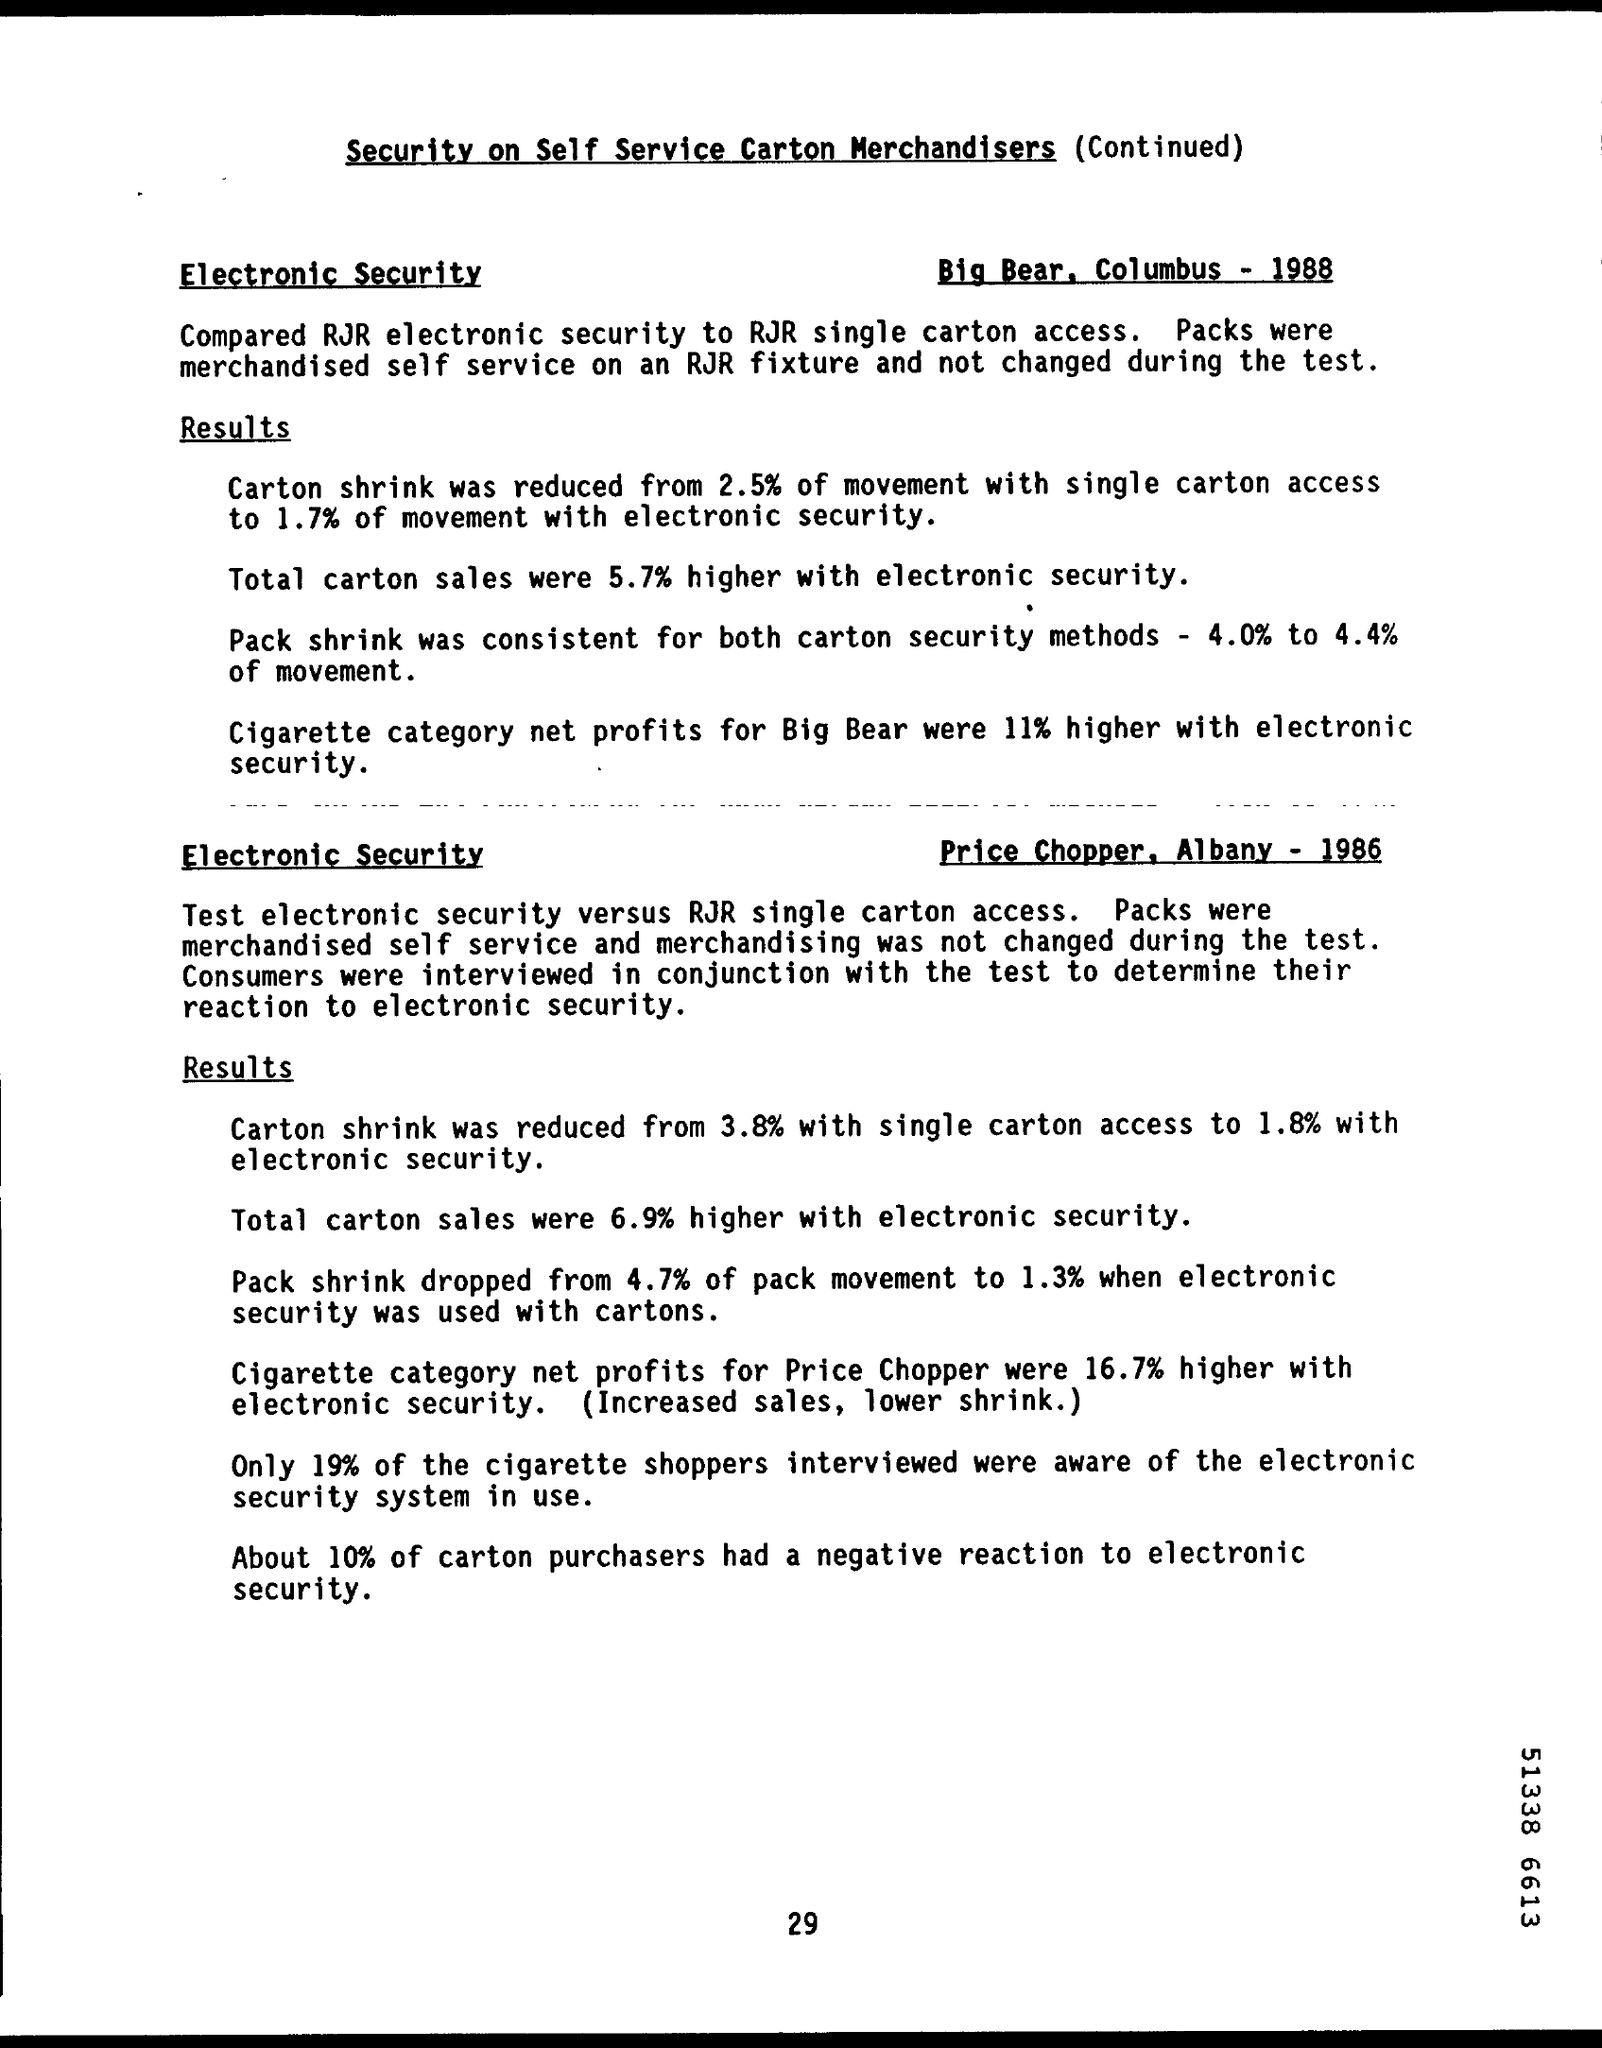Point out several critical features in this image. The sales of total cartons with electronic security in Big Bear increased by 5.7% compared to the previous year. The document title is "Security on Self Service Carton Merchandisers (Continued). In Albany, approximately 10% of carton purchasers had a negative reaction to electronic security. 